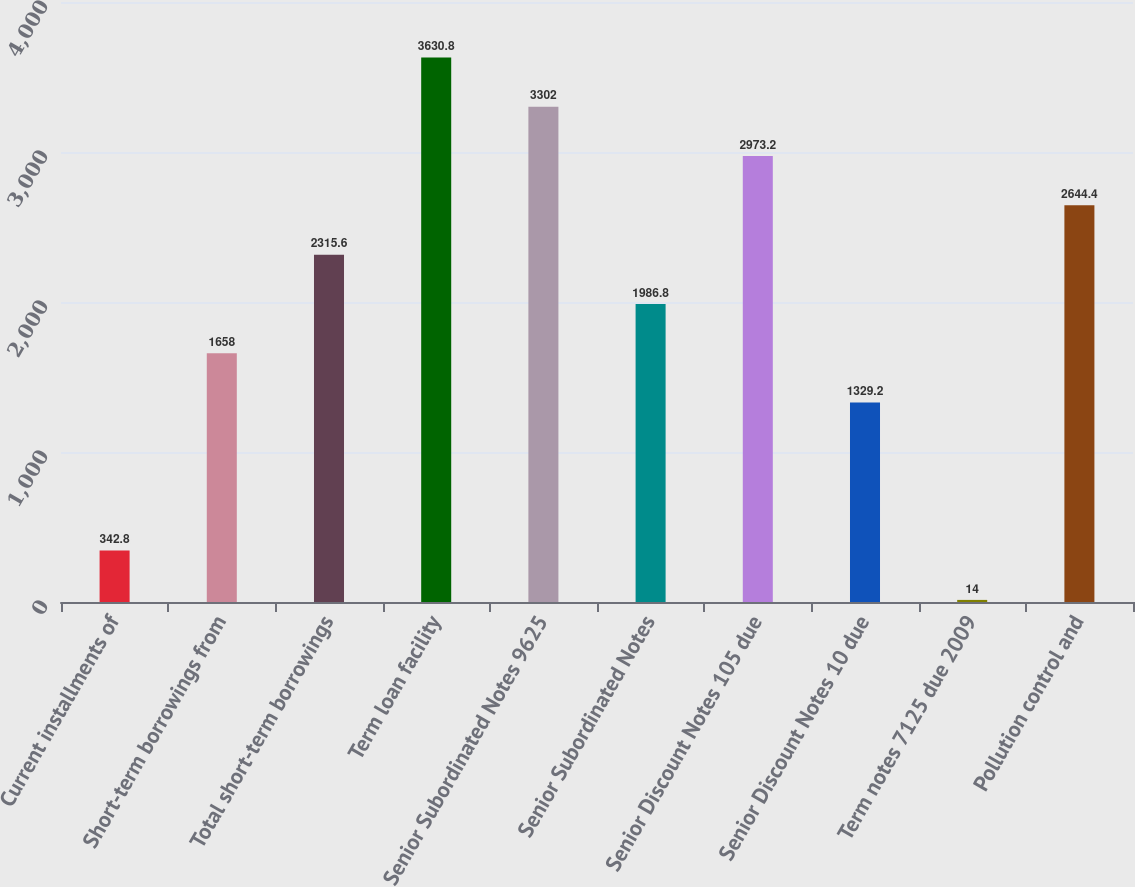Convert chart. <chart><loc_0><loc_0><loc_500><loc_500><bar_chart><fcel>Current installments of<fcel>Short-term borrowings from<fcel>Total short-term borrowings<fcel>Term loan facility<fcel>Senior Subordinated Notes 9625<fcel>Senior Subordinated Notes<fcel>Senior Discount Notes 105 due<fcel>Senior Discount Notes 10 due<fcel>Term notes 7125 due 2009<fcel>Pollution control and<nl><fcel>342.8<fcel>1658<fcel>2315.6<fcel>3630.8<fcel>3302<fcel>1986.8<fcel>2973.2<fcel>1329.2<fcel>14<fcel>2644.4<nl></chart> 